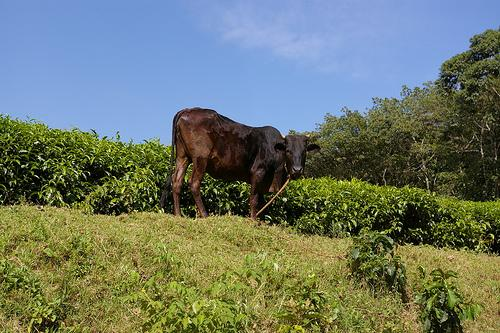Provide a creative and vivid description of the scenery in the image. Underneath a serene sky with wispy white clouds, a picturesque scene unfolds as a curious, skinny cow with a prominent gaze faces the camera, with a verdant background of hedged bushes and towering trees. Describe the image with a focus on the main animal and its surrounding environment. A black and brown cow gazes directly into the camera amidst a lush, green pasture filled with bushes and trees, set against a clear blue sky scattered with puffy clouds. Discuss the main subject's physical appearance and its interaction with the camera. The lean cow flaunts an interesting blend of black and brown colors in its coat, and stands on its sturdy legs within the green pasture, its attention caught by the camera as it directly faces it with an unmistakable curiosity. Describe the image focusing on the facial features of the main subject. The cow's face, an intriguing mix of black and brown, features expressive eyes and ears that seem attentive to the camera, while its nose is clearly visible amidst the spacious green background. Narrate the scene in the image as if you are describing it to someone who cannot see it. Imagine standing in front of a green field where a dark brown cow, adorned with a charming rope, surveys the landscape with its keen eyes and captivating expression. The cow is surrounded by thick bushes and towering trees, while overhead, a beautiful sky stretches endlessly. Using a poetic tone, describe the key elements in the image. In nature's verdant embrace, stands a cow of deep earthy hues, a taut leash around her proud neck. She beholds the camera with her piercing gaze, while the sky, donning a celestial dress of azure, cradles the wispiest of clouds aloft. Provide a description of the image focused on the presence of trees and vegetation. Amidst a luscious, green backdrop of hedged bushes, leafy trees, and vibrant grass, a mesmerizing cow with a distinct coat catches the viewer's attention as it gazes into the camera with keen interest. Describe the overall atmosphere and mood of the image. The image evokes a peaceful and serene atmosphere, as an attentive cow captivates the viewer with its gaze amidst a lush, green landscape, while a pristine sky with gentle clouds watches over the tranquil scene. Write a brief summary of the main elements present in the image. A dark brown cow stands on a green, grassy field with hedged bushes and row of trees behind it, while wearing a brown rope around its neck and looking towards the camera. Explain the key colors and elements in the image that make it visually interesting. The intertwining hues of black and brown in the cow, contrasting with the vibrant greens of the grass and bushes, and the soothing blues of the sky with specks of joyful white clouds, create a mesmerizing visual experience. 